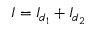<formula> <loc_0><loc_0><loc_500><loc_500>I = I _ { d _ { 1 } } + I _ { d _ { 2 } }</formula> 